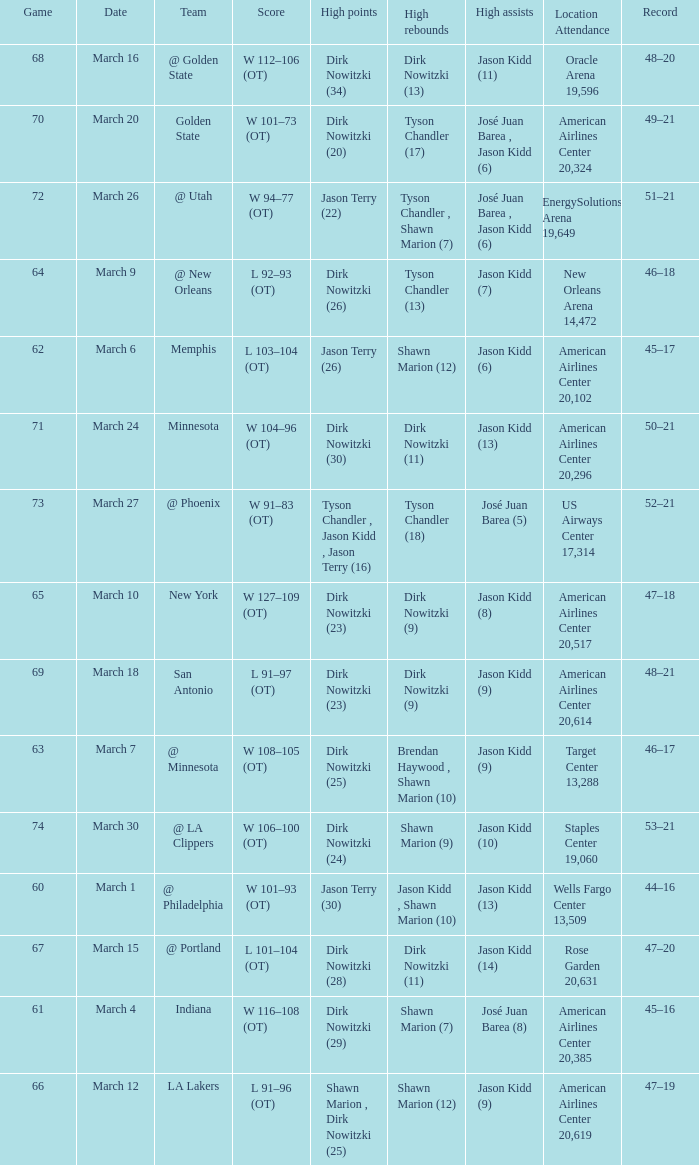Name the high assists for  l 103–104 (ot) Jason Kidd (6). 